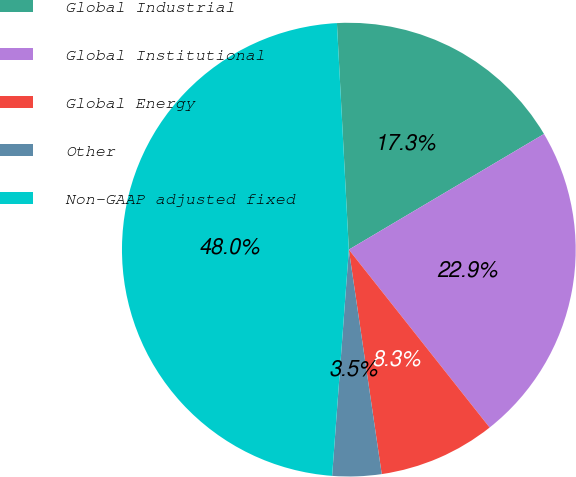Convert chart to OTSL. <chart><loc_0><loc_0><loc_500><loc_500><pie_chart><fcel>Global Industrial<fcel>Global Institutional<fcel>Global Energy<fcel>Other<fcel>Non-GAAP adjusted fixed<nl><fcel>17.32%<fcel>22.86%<fcel>8.34%<fcel>3.49%<fcel>47.99%<nl></chart> 